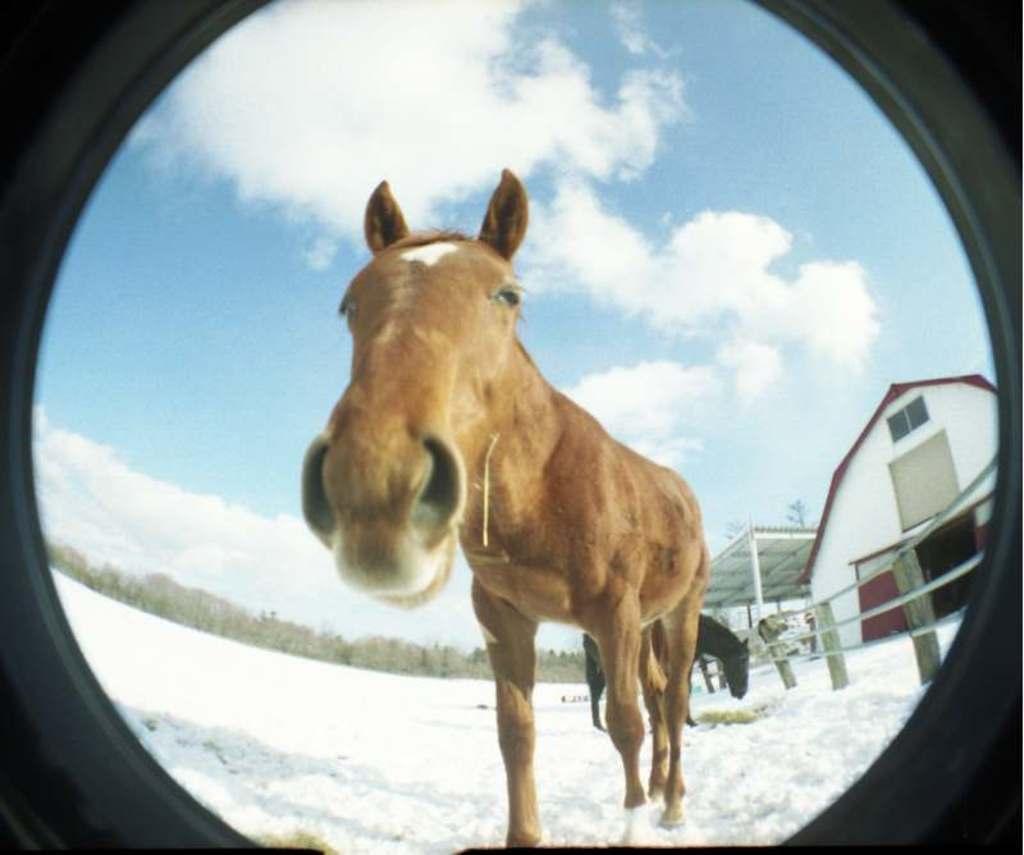Can you describe this image briefly? It looks like an edited image. There are two horses standing on the snow. On the right side of the image, there is a shed, house and a fence. In the background, there are trees and the sky. 